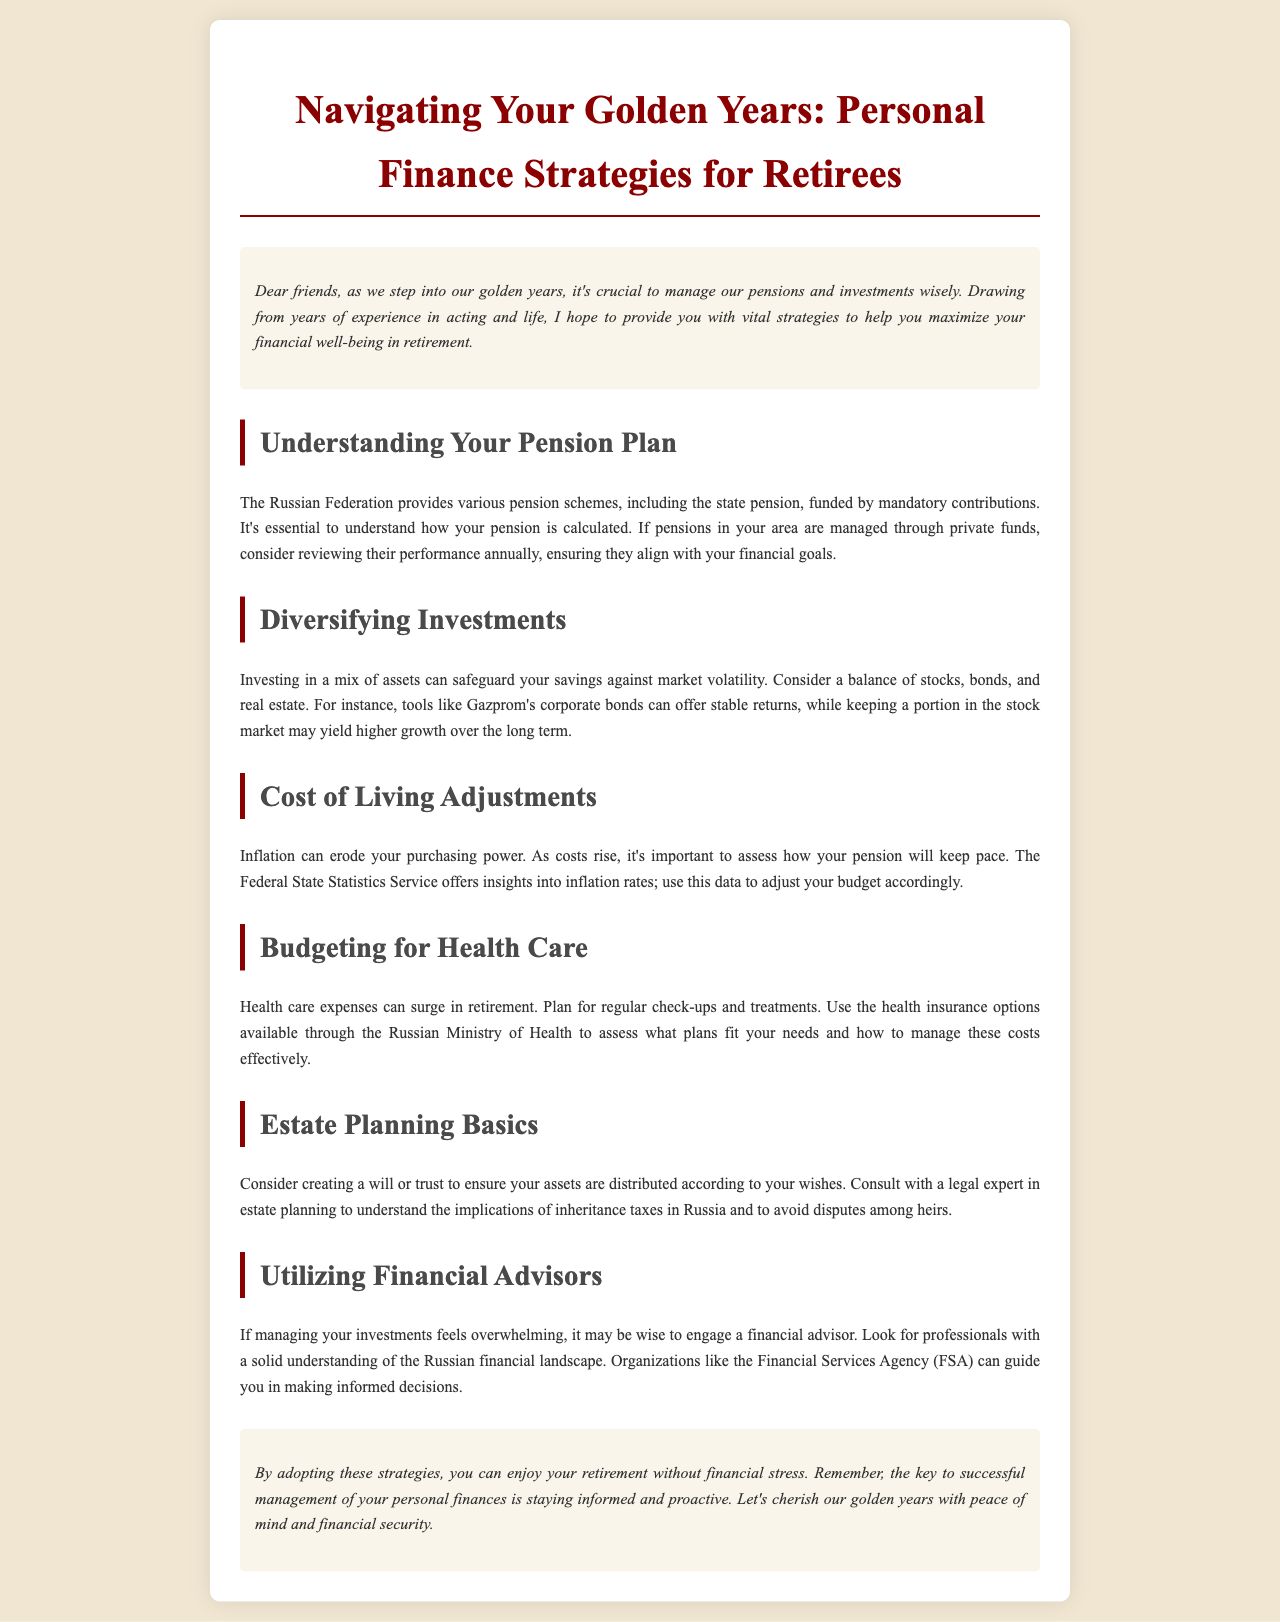What is the title of the newsletter? The title is stated prominently at the beginning of the document, emphasizing the focus on personal finance strategies for retirees.
Answer: Navigating Your Golden Years: Personal Finance Strategies for Retirees What should you review annually? The document specifies that reviewing the performance of pension funds is essential for aligning with financial goals.
Answer: Pension funds What can inflation erode? The document addresses the impact of inflation on finances, specifically mentioning what may decrease in value over time.
Answer: Purchasing power What is one corporation mentioned for investment? The newsletter suggests a specific type of investment mentioned within the section on diversifying investments.
Answer: Gazprom What is a key element to consider in estate planning? The document discusses the importance of a legal document for ensuring asset distribution according to wishes.
Answer: Will or trust Who is advised to be consulted for estate planning? The document recommends a specific type of professional to seek guidance on estate-related matters.
Answer: Legal expert Which organization can assist in engaging financial advisors? The newsletter mentions an organization that provides guidance on financial planning and advice in the context of Russian finance.
Answer: Financial Services Agency What is the purpose of budgeting for health care? The document outlines a specific reason for why retirees should manage health care expenses.
Answer: Plan for regular check-ups and treatments 